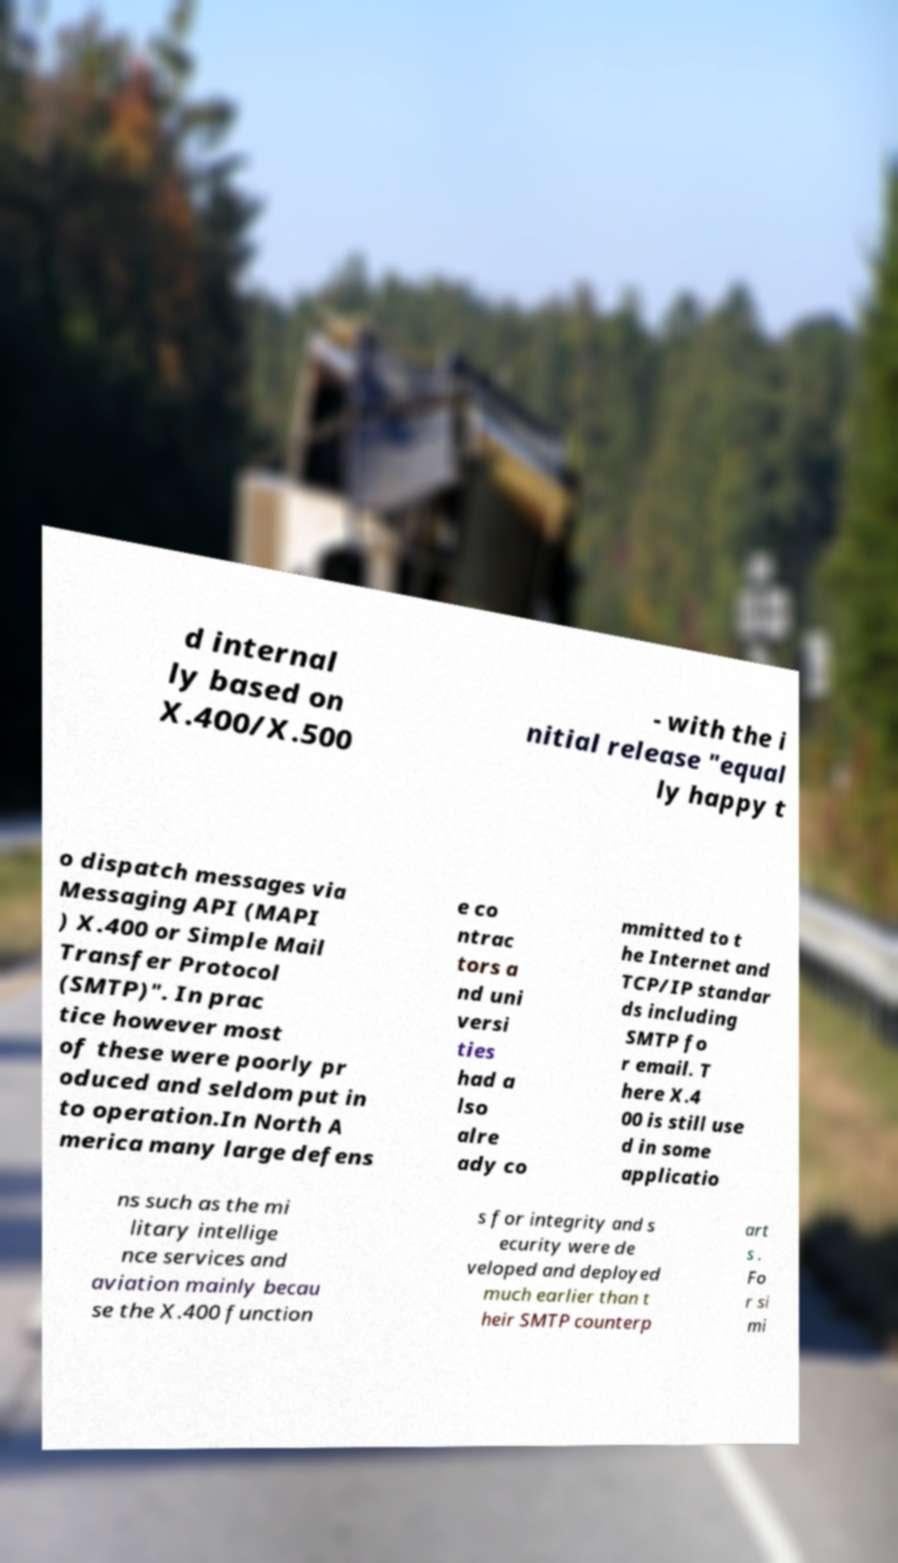For documentation purposes, I need the text within this image transcribed. Could you provide that? d internal ly based on X.400/X.500 - with the i nitial release "equal ly happy t o dispatch messages via Messaging API (MAPI ) X.400 or Simple Mail Transfer Protocol (SMTP)". In prac tice however most of these were poorly pr oduced and seldom put in to operation.In North A merica many large defens e co ntrac tors a nd uni versi ties had a lso alre ady co mmitted to t he Internet and TCP/IP standar ds including SMTP fo r email. T here X.4 00 is still use d in some applicatio ns such as the mi litary intellige nce services and aviation mainly becau se the X.400 function s for integrity and s ecurity were de veloped and deployed much earlier than t heir SMTP counterp art s . Fo r si mi 